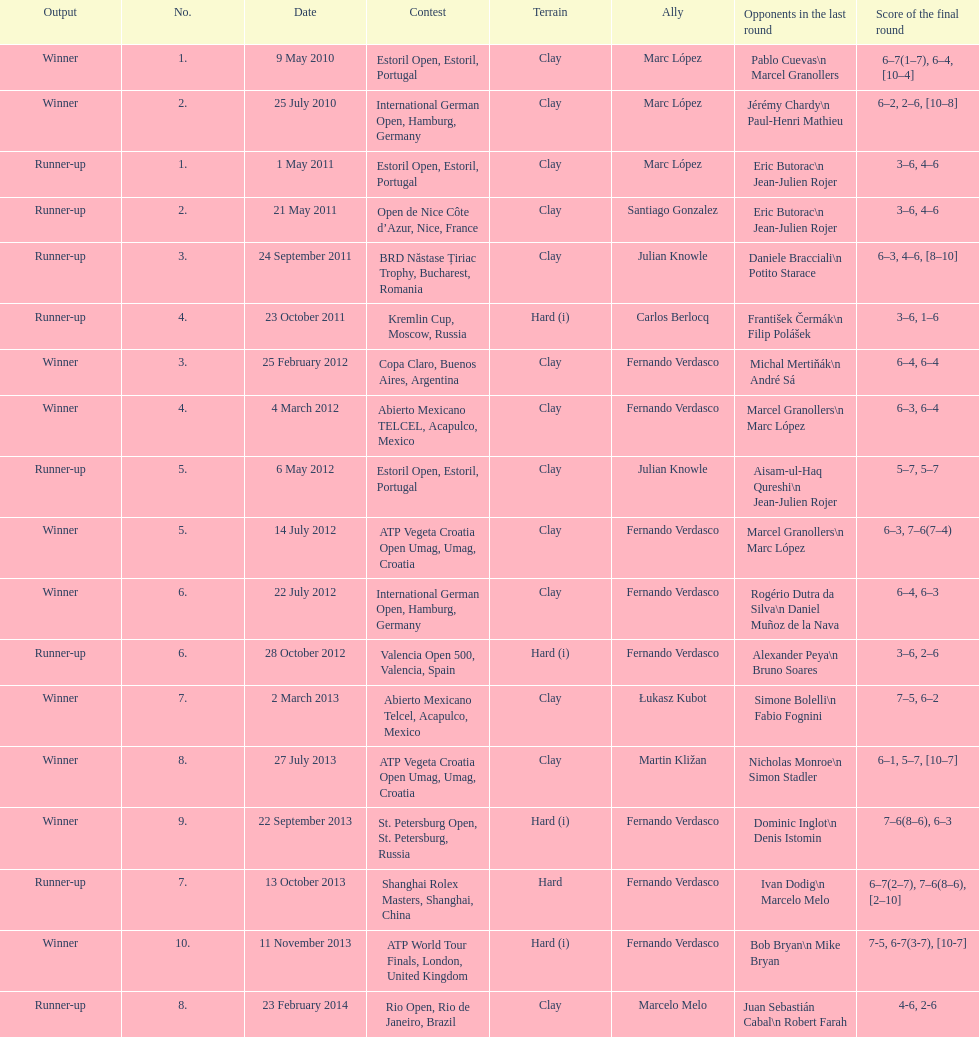How many winners are there? 10. 